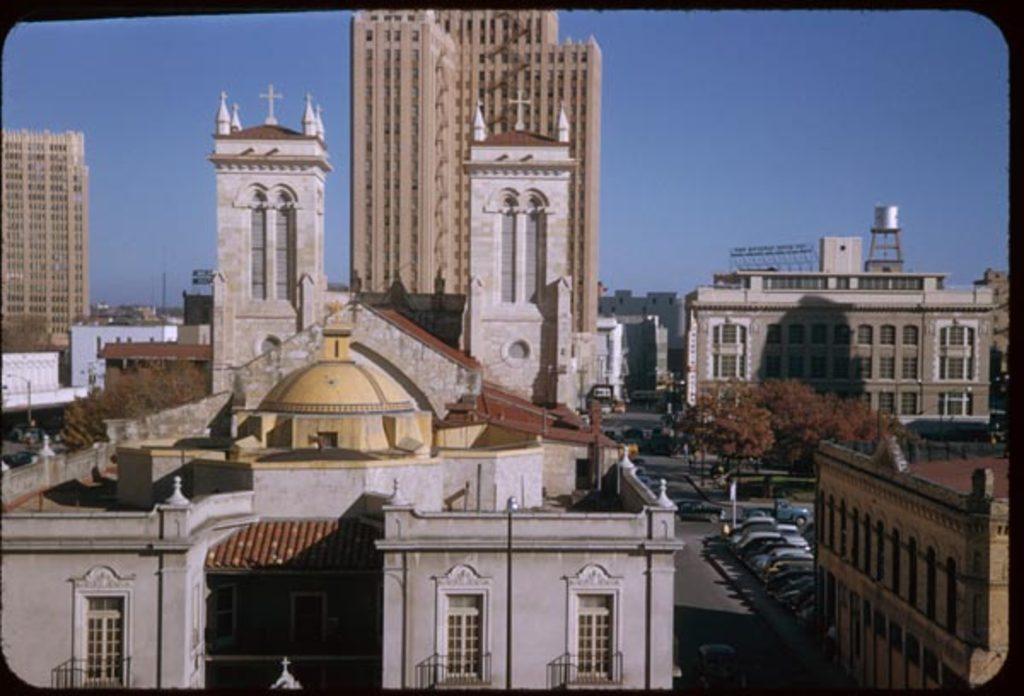Can you describe this image briefly? In the image there are many buildings with walls, windows, balconies and roofs. Also there are poles with light. There is a road with few vehicles. At the top of the image in the background there is a sky. 